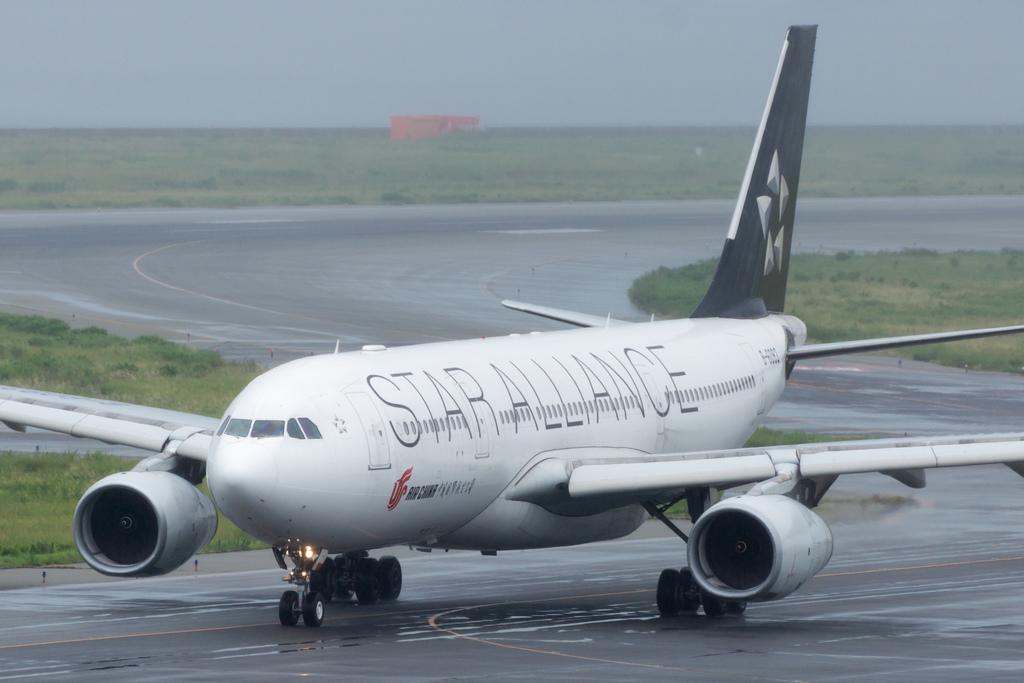<image>
Render a clear and concise summary of the photo. A Star Alliance passenger plane is on the tarmac on a rainy day. 